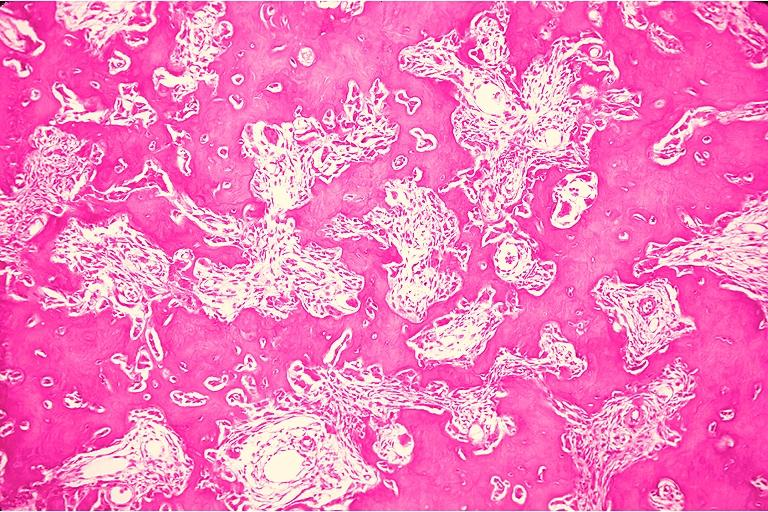what is present?
Answer the question using a single word or phrase. Oral 